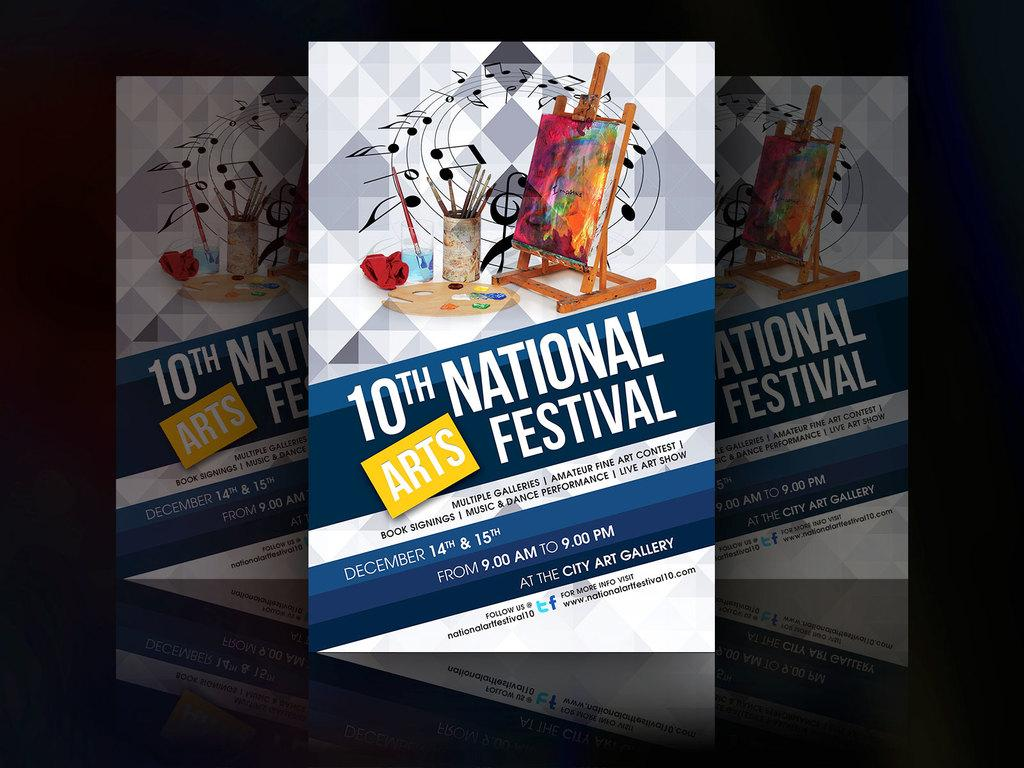What is present on the glass surface in the image? There are three posters on a glass surface in the image. Can you describe the background of the image? The background of the image is dark. What type of wax can be seen melting on the glass surface in the image? There is no wax present in the image; it only features three posters on a glass surface. Can you describe the scarecrow standing next to the posters in the image? There is no scarecrow present in the image; it only features three posters on a glass surface with a dark background. 